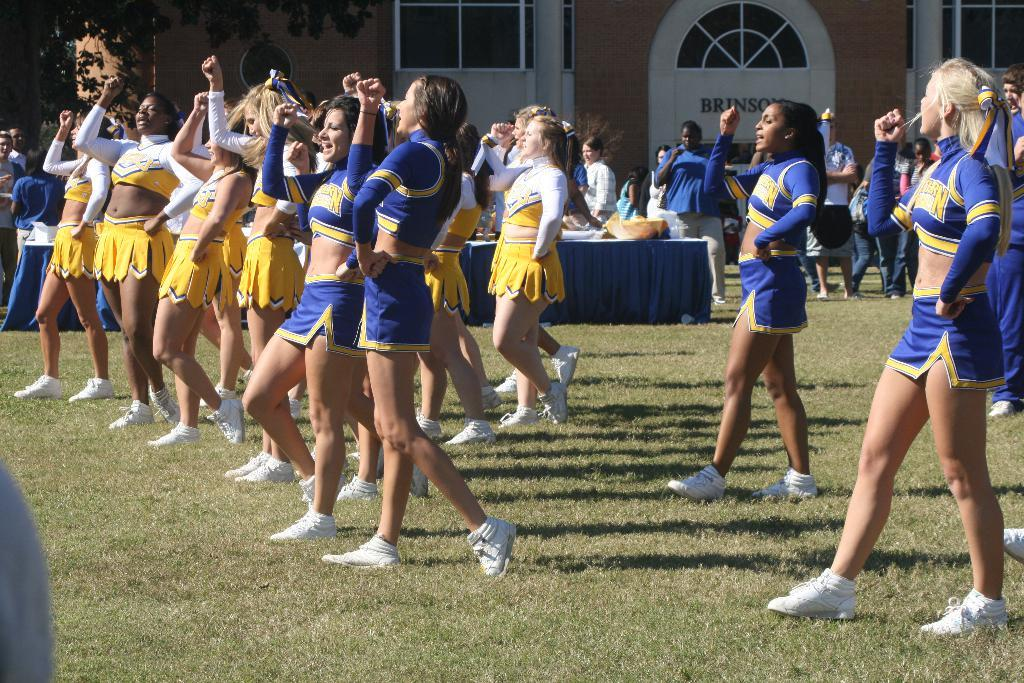<image>
Describe the image concisely. Cheerleaders stand in front of a building called Brinson while cheering on the crowd 